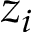Convert formula to latex. <formula><loc_0><loc_0><loc_500><loc_500>z _ { i }</formula> 